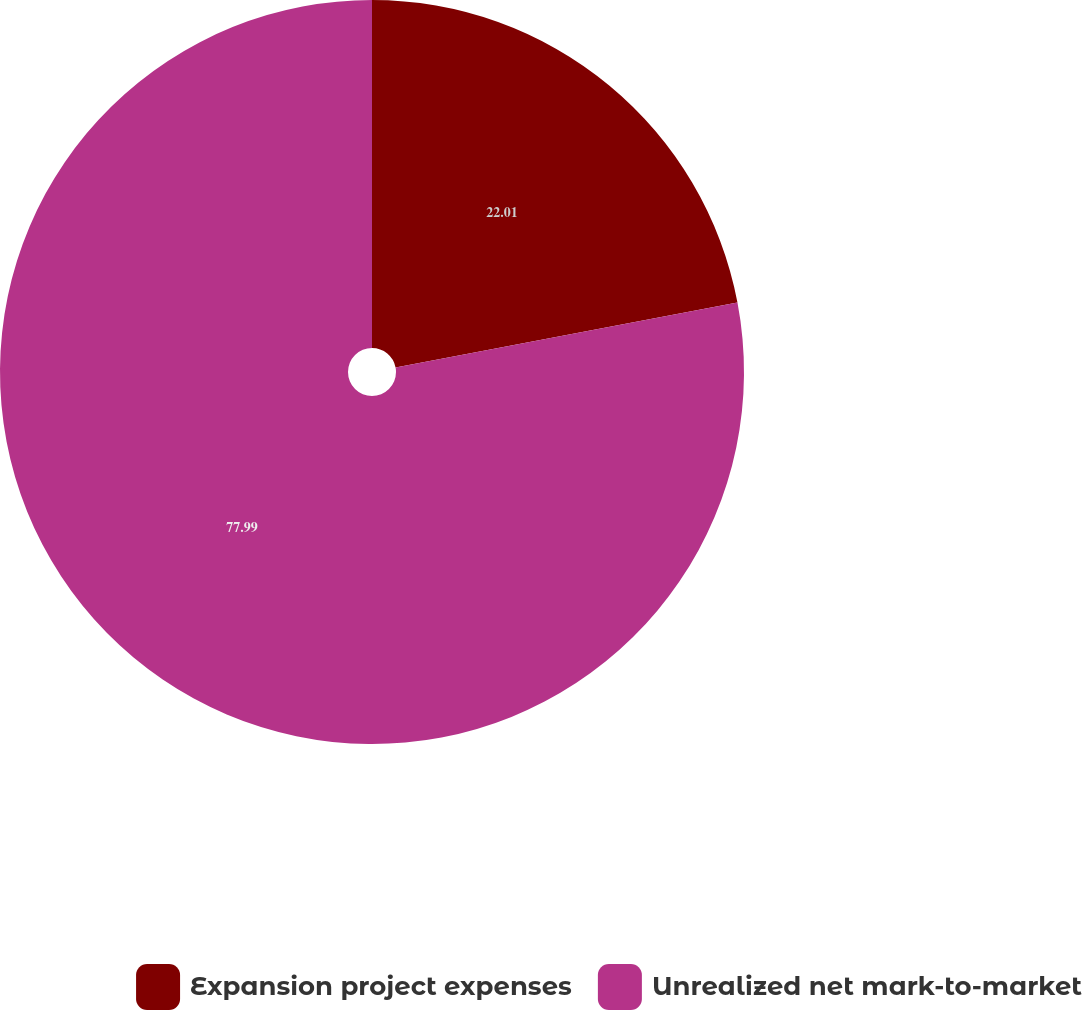<chart> <loc_0><loc_0><loc_500><loc_500><pie_chart><fcel>Expansion project expenses<fcel>Unrealized net mark-to-market<nl><fcel>22.01%<fcel>77.99%<nl></chart> 